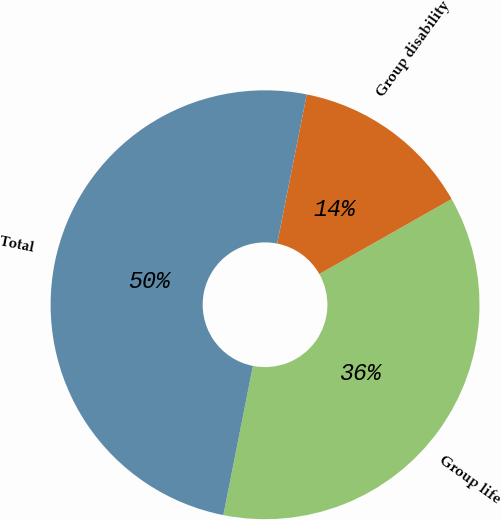Convert chart. <chart><loc_0><loc_0><loc_500><loc_500><pie_chart><fcel>Group life<fcel>Group disability<fcel>Total<nl><fcel>36.32%<fcel>13.68%<fcel>50.0%<nl></chart> 